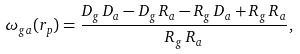Convert formula to latex. <formula><loc_0><loc_0><loc_500><loc_500>\omega _ { g a } ( r _ { p } ) = \frac { D _ { g } \, D _ { a } - D _ { g } \, R _ { a } - R _ { g } \, D _ { a } + R _ { g } \, R _ { a } } { R _ { g } \, R _ { a } } ,</formula> 